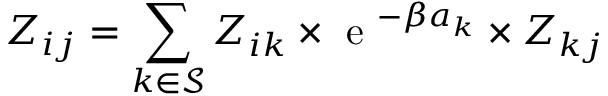<formula> <loc_0><loc_0><loc_500><loc_500>Z _ { i j } = \sum _ { k \in \mathcal { S } } Z _ { i k } \times e ^ { - \beta a _ { k } } \times Z _ { k j }</formula> 